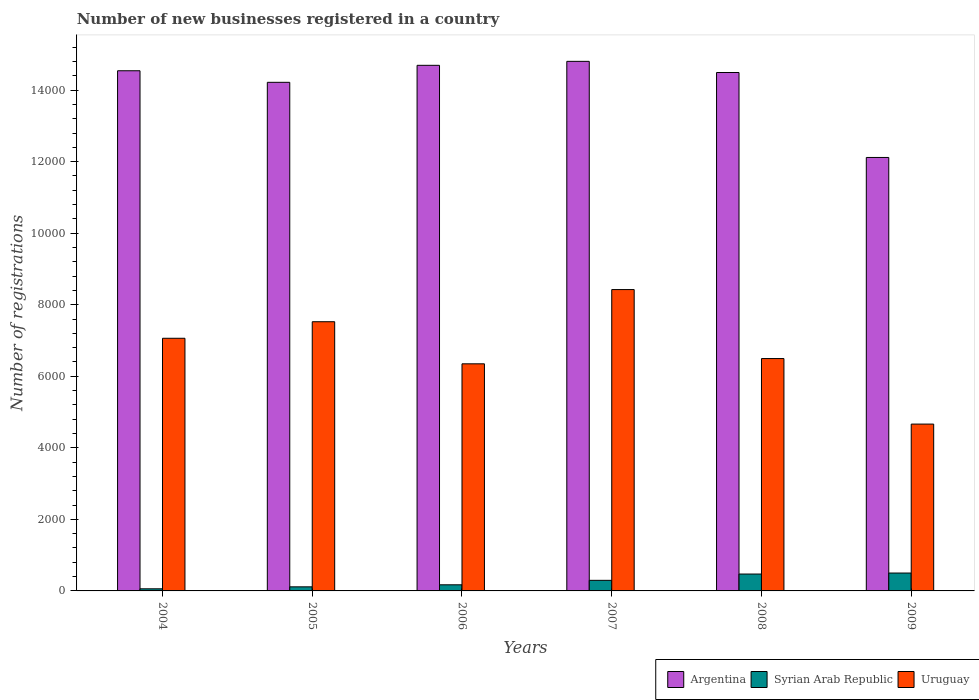How many different coloured bars are there?
Make the answer very short. 3. Are the number of bars on each tick of the X-axis equal?
Your answer should be compact. Yes. How many bars are there on the 6th tick from the left?
Keep it short and to the point. 3. What is the label of the 1st group of bars from the left?
Your answer should be compact. 2004. What is the number of new businesses registered in Uruguay in 2006?
Offer a terse response. 6349. Across all years, what is the maximum number of new businesses registered in Argentina?
Make the answer very short. 1.48e+04. Across all years, what is the minimum number of new businesses registered in Argentina?
Your answer should be compact. 1.21e+04. In which year was the number of new businesses registered in Uruguay maximum?
Provide a short and direct response. 2007. In which year was the number of new businesses registered in Syrian Arab Republic minimum?
Make the answer very short. 2004. What is the total number of new businesses registered in Syrian Arab Republic in the graph?
Your answer should be very brief. 1612. What is the difference between the number of new businesses registered in Syrian Arab Republic in 2007 and that in 2009?
Your answer should be very brief. -204. What is the difference between the number of new businesses registered in Argentina in 2007 and the number of new businesses registered in Uruguay in 2005?
Your answer should be very brief. 7279. What is the average number of new businesses registered in Syrian Arab Republic per year?
Make the answer very short. 268.67. In the year 2007, what is the difference between the number of new businesses registered in Syrian Arab Republic and number of new businesses registered in Uruguay?
Keep it short and to the point. -8129. What is the ratio of the number of new businesses registered in Syrian Arab Republic in 2005 to that in 2006?
Keep it short and to the point. 0.67. Is the difference between the number of new businesses registered in Syrian Arab Republic in 2005 and 2009 greater than the difference between the number of new businesses registered in Uruguay in 2005 and 2009?
Provide a short and direct response. No. What is the difference between the highest and the second highest number of new businesses registered in Argentina?
Keep it short and to the point. 111. What is the difference between the highest and the lowest number of new businesses registered in Uruguay?
Give a very brief answer. 3761. Is the sum of the number of new businesses registered in Argentina in 2005 and 2006 greater than the maximum number of new businesses registered in Uruguay across all years?
Offer a very short reply. Yes. What does the 1st bar from the left in 2005 represents?
Provide a succinct answer. Argentina. What does the 1st bar from the right in 2009 represents?
Your response must be concise. Uruguay. Is it the case that in every year, the sum of the number of new businesses registered in Syrian Arab Republic and number of new businesses registered in Uruguay is greater than the number of new businesses registered in Argentina?
Provide a short and direct response. No. How many bars are there?
Ensure brevity in your answer.  18. Does the graph contain any zero values?
Make the answer very short. No. Where does the legend appear in the graph?
Ensure brevity in your answer.  Bottom right. How are the legend labels stacked?
Keep it short and to the point. Horizontal. What is the title of the graph?
Make the answer very short. Number of new businesses registered in a country. What is the label or title of the X-axis?
Keep it short and to the point. Years. What is the label or title of the Y-axis?
Keep it short and to the point. Number of registrations. What is the Number of registrations of Argentina in 2004?
Ensure brevity in your answer.  1.45e+04. What is the Number of registrations in Syrian Arab Republic in 2004?
Ensure brevity in your answer.  59. What is the Number of registrations of Uruguay in 2004?
Your answer should be very brief. 7063. What is the Number of registrations in Argentina in 2005?
Provide a short and direct response. 1.42e+04. What is the Number of registrations of Syrian Arab Republic in 2005?
Offer a terse response. 114. What is the Number of registrations in Uruguay in 2005?
Keep it short and to the point. 7526. What is the Number of registrations in Argentina in 2006?
Offer a very short reply. 1.47e+04. What is the Number of registrations of Syrian Arab Republic in 2006?
Provide a short and direct response. 171. What is the Number of registrations of Uruguay in 2006?
Offer a very short reply. 6349. What is the Number of registrations of Argentina in 2007?
Your response must be concise. 1.48e+04. What is the Number of registrations in Syrian Arab Republic in 2007?
Provide a short and direct response. 296. What is the Number of registrations in Uruguay in 2007?
Your response must be concise. 8425. What is the Number of registrations in Argentina in 2008?
Ensure brevity in your answer.  1.45e+04. What is the Number of registrations in Syrian Arab Republic in 2008?
Your answer should be very brief. 472. What is the Number of registrations of Uruguay in 2008?
Your answer should be very brief. 6496. What is the Number of registrations of Argentina in 2009?
Offer a terse response. 1.21e+04. What is the Number of registrations of Uruguay in 2009?
Offer a very short reply. 4664. Across all years, what is the maximum Number of registrations of Argentina?
Your response must be concise. 1.48e+04. Across all years, what is the maximum Number of registrations in Syrian Arab Republic?
Offer a very short reply. 500. Across all years, what is the maximum Number of registrations in Uruguay?
Your answer should be compact. 8425. Across all years, what is the minimum Number of registrations in Argentina?
Offer a very short reply. 1.21e+04. Across all years, what is the minimum Number of registrations in Uruguay?
Your answer should be very brief. 4664. What is the total Number of registrations in Argentina in the graph?
Offer a terse response. 8.49e+04. What is the total Number of registrations in Syrian Arab Republic in the graph?
Your response must be concise. 1612. What is the total Number of registrations in Uruguay in the graph?
Provide a succinct answer. 4.05e+04. What is the difference between the Number of registrations of Argentina in 2004 and that in 2005?
Give a very brief answer. 323. What is the difference between the Number of registrations in Syrian Arab Republic in 2004 and that in 2005?
Provide a succinct answer. -55. What is the difference between the Number of registrations of Uruguay in 2004 and that in 2005?
Keep it short and to the point. -463. What is the difference between the Number of registrations in Argentina in 2004 and that in 2006?
Offer a terse response. -152. What is the difference between the Number of registrations of Syrian Arab Republic in 2004 and that in 2006?
Offer a terse response. -112. What is the difference between the Number of registrations in Uruguay in 2004 and that in 2006?
Your answer should be compact. 714. What is the difference between the Number of registrations in Argentina in 2004 and that in 2007?
Give a very brief answer. -263. What is the difference between the Number of registrations of Syrian Arab Republic in 2004 and that in 2007?
Offer a terse response. -237. What is the difference between the Number of registrations of Uruguay in 2004 and that in 2007?
Offer a terse response. -1362. What is the difference between the Number of registrations of Syrian Arab Republic in 2004 and that in 2008?
Provide a short and direct response. -413. What is the difference between the Number of registrations of Uruguay in 2004 and that in 2008?
Provide a short and direct response. 567. What is the difference between the Number of registrations in Argentina in 2004 and that in 2009?
Your response must be concise. 2424. What is the difference between the Number of registrations of Syrian Arab Republic in 2004 and that in 2009?
Provide a short and direct response. -441. What is the difference between the Number of registrations of Uruguay in 2004 and that in 2009?
Ensure brevity in your answer.  2399. What is the difference between the Number of registrations of Argentina in 2005 and that in 2006?
Your answer should be compact. -475. What is the difference between the Number of registrations in Syrian Arab Republic in 2005 and that in 2006?
Ensure brevity in your answer.  -57. What is the difference between the Number of registrations in Uruguay in 2005 and that in 2006?
Give a very brief answer. 1177. What is the difference between the Number of registrations in Argentina in 2005 and that in 2007?
Provide a short and direct response. -586. What is the difference between the Number of registrations of Syrian Arab Republic in 2005 and that in 2007?
Ensure brevity in your answer.  -182. What is the difference between the Number of registrations of Uruguay in 2005 and that in 2007?
Make the answer very short. -899. What is the difference between the Number of registrations of Argentina in 2005 and that in 2008?
Make the answer very short. -274. What is the difference between the Number of registrations of Syrian Arab Republic in 2005 and that in 2008?
Your answer should be compact. -358. What is the difference between the Number of registrations of Uruguay in 2005 and that in 2008?
Your response must be concise. 1030. What is the difference between the Number of registrations in Argentina in 2005 and that in 2009?
Offer a very short reply. 2101. What is the difference between the Number of registrations of Syrian Arab Republic in 2005 and that in 2009?
Offer a very short reply. -386. What is the difference between the Number of registrations of Uruguay in 2005 and that in 2009?
Offer a terse response. 2862. What is the difference between the Number of registrations in Argentina in 2006 and that in 2007?
Provide a succinct answer. -111. What is the difference between the Number of registrations in Syrian Arab Republic in 2006 and that in 2007?
Make the answer very short. -125. What is the difference between the Number of registrations in Uruguay in 2006 and that in 2007?
Make the answer very short. -2076. What is the difference between the Number of registrations in Argentina in 2006 and that in 2008?
Give a very brief answer. 201. What is the difference between the Number of registrations in Syrian Arab Republic in 2006 and that in 2008?
Provide a short and direct response. -301. What is the difference between the Number of registrations in Uruguay in 2006 and that in 2008?
Keep it short and to the point. -147. What is the difference between the Number of registrations in Argentina in 2006 and that in 2009?
Make the answer very short. 2576. What is the difference between the Number of registrations in Syrian Arab Republic in 2006 and that in 2009?
Ensure brevity in your answer.  -329. What is the difference between the Number of registrations of Uruguay in 2006 and that in 2009?
Give a very brief answer. 1685. What is the difference between the Number of registrations of Argentina in 2007 and that in 2008?
Ensure brevity in your answer.  312. What is the difference between the Number of registrations of Syrian Arab Republic in 2007 and that in 2008?
Offer a very short reply. -176. What is the difference between the Number of registrations in Uruguay in 2007 and that in 2008?
Make the answer very short. 1929. What is the difference between the Number of registrations of Argentina in 2007 and that in 2009?
Provide a succinct answer. 2687. What is the difference between the Number of registrations in Syrian Arab Republic in 2007 and that in 2009?
Your answer should be compact. -204. What is the difference between the Number of registrations of Uruguay in 2007 and that in 2009?
Your answer should be compact. 3761. What is the difference between the Number of registrations in Argentina in 2008 and that in 2009?
Ensure brevity in your answer.  2375. What is the difference between the Number of registrations in Syrian Arab Republic in 2008 and that in 2009?
Your answer should be compact. -28. What is the difference between the Number of registrations in Uruguay in 2008 and that in 2009?
Your answer should be very brief. 1832. What is the difference between the Number of registrations in Argentina in 2004 and the Number of registrations in Syrian Arab Republic in 2005?
Offer a terse response. 1.44e+04. What is the difference between the Number of registrations of Argentina in 2004 and the Number of registrations of Uruguay in 2005?
Your response must be concise. 7016. What is the difference between the Number of registrations in Syrian Arab Republic in 2004 and the Number of registrations in Uruguay in 2005?
Offer a terse response. -7467. What is the difference between the Number of registrations of Argentina in 2004 and the Number of registrations of Syrian Arab Republic in 2006?
Make the answer very short. 1.44e+04. What is the difference between the Number of registrations of Argentina in 2004 and the Number of registrations of Uruguay in 2006?
Offer a terse response. 8193. What is the difference between the Number of registrations in Syrian Arab Republic in 2004 and the Number of registrations in Uruguay in 2006?
Give a very brief answer. -6290. What is the difference between the Number of registrations of Argentina in 2004 and the Number of registrations of Syrian Arab Republic in 2007?
Provide a short and direct response. 1.42e+04. What is the difference between the Number of registrations of Argentina in 2004 and the Number of registrations of Uruguay in 2007?
Your answer should be compact. 6117. What is the difference between the Number of registrations of Syrian Arab Republic in 2004 and the Number of registrations of Uruguay in 2007?
Keep it short and to the point. -8366. What is the difference between the Number of registrations in Argentina in 2004 and the Number of registrations in Syrian Arab Republic in 2008?
Give a very brief answer. 1.41e+04. What is the difference between the Number of registrations of Argentina in 2004 and the Number of registrations of Uruguay in 2008?
Give a very brief answer. 8046. What is the difference between the Number of registrations in Syrian Arab Republic in 2004 and the Number of registrations in Uruguay in 2008?
Offer a terse response. -6437. What is the difference between the Number of registrations of Argentina in 2004 and the Number of registrations of Syrian Arab Republic in 2009?
Keep it short and to the point. 1.40e+04. What is the difference between the Number of registrations of Argentina in 2004 and the Number of registrations of Uruguay in 2009?
Your response must be concise. 9878. What is the difference between the Number of registrations in Syrian Arab Republic in 2004 and the Number of registrations in Uruguay in 2009?
Offer a terse response. -4605. What is the difference between the Number of registrations in Argentina in 2005 and the Number of registrations in Syrian Arab Republic in 2006?
Offer a very short reply. 1.40e+04. What is the difference between the Number of registrations in Argentina in 2005 and the Number of registrations in Uruguay in 2006?
Offer a very short reply. 7870. What is the difference between the Number of registrations in Syrian Arab Republic in 2005 and the Number of registrations in Uruguay in 2006?
Offer a terse response. -6235. What is the difference between the Number of registrations of Argentina in 2005 and the Number of registrations of Syrian Arab Republic in 2007?
Make the answer very short. 1.39e+04. What is the difference between the Number of registrations of Argentina in 2005 and the Number of registrations of Uruguay in 2007?
Offer a terse response. 5794. What is the difference between the Number of registrations of Syrian Arab Republic in 2005 and the Number of registrations of Uruguay in 2007?
Your response must be concise. -8311. What is the difference between the Number of registrations of Argentina in 2005 and the Number of registrations of Syrian Arab Republic in 2008?
Make the answer very short. 1.37e+04. What is the difference between the Number of registrations in Argentina in 2005 and the Number of registrations in Uruguay in 2008?
Offer a terse response. 7723. What is the difference between the Number of registrations of Syrian Arab Republic in 2005 and the Number of registrations of Uruguay in 2008?
Your response must be concise. -6382. What is the difference between the Number of registrations of Argentina in 2005 and the Number of registrations of Syrian Arab Republic in 2009?
Make the answer very short. 1.37e+04. What is the difference between the Number of registrations in Argentina in 2005 and the Number of registrations in Uruguay in 2009?
Offer a terse response. 9555. What is the difference between the Number of registrations of Syrian Arab Republic in 2005 and the Number of registrations of Uruguay in 2009?
Provide a succinct answer. -4550. What is the difference between the Number of registrations in Argentina in 2006 and the Number of registrations in Syrian Arab Republic in 2007?
Offer a very short reply. 1.44e+04. What is the difference between the Number of registrations of Argentina in 2006 and the Number of registrations of Uruguay in 2007?
Ensure brevity in your answer.  6269. What is the difference between the Number of registrations in Syrian Arab Republic in 2006 and the Number of registrations in Uruguay in 2007?
Your answer should be compact. -8254. What is the difference between the Number of registrations of Argentina in 2006 and the Number of registrations of Syrian Arab Republic in 2008?
Offer a very short reply. 1.42e+04. What is the difference between the Number of registrations of Argentina in 2006 and the Number of registrations of Uruguay in 2008?
Give a very brief answer. 8198. What is the difference between the Number of registrations in Syrian Arab Republic in 2006 and the Number of registrations in Uruguay in 2008?
Offer a very short reply. -6325. What is the difference between the Number of registrations in Argentina in 2006 and the Number of registrations in Syrian Arab Republic in 2009?
Your answer should be very brief. 1.42e+04. What is the difference between the Number of registrations of Argentina in 2006 and the Number of registrations of Uruguay in 2009?
Offer a very short reply. 1.00e+04. What is the difference between the Number of registrations of Syrian Arab Republic in 2006 and the Number of registrations of Uruguay in 2009?
Your answer should be compact. -4493. What is the difference between the Number of registrations of Argentina in 2007 and the Number of registrations of Syrian Arab Republic in 2008?
Give a very brief answer. 1.43e+04. What is the difference between the Number of registrations of Argentina in 2007 and the Number of registrations of Uruguay in 2008?
Make the answer very short. 8309. What is the difference between the Number of registrations in Syrian Arab Republic in 2007 and the Number of registrations in Uruguay in 2008?
Your answer should be compact. -6200. What is the difference between the Number of registrations of Argentina in 2007 and the Number of registrations of Syrian Arab Republic in 2009?
Ensure brevity in your answer.  1.43e+04. What is the difference between the Number of registrations of Argentina in 2007 and the Number of registrations of Uruguay in 2009?
Provide a short and direct response. 1.01e+04. What is the difference between the Number of registrations of Syrian Arab Republic in 2007 and the Number of registrations of Uruguay in 2009?
Provide a short and direct response. -4368. What is the difference between the Number of registrations of Argentina in 2008 and the Number of registrations of Syrian Arab Republic in 2009?
Offer a terse response. 1.40e+04. What is the difference between the Number of registrations in Argentina in 2008 and the Number of registrations in Uruguay in 2009?
Keep it short and to the point. 9829. What is the difference between the Number of registrations of Syrian Arab Republic in 2008 and the Number of registrations of Uruguay in 2009?
Offer a terse response. -4192. What is the average Number of registrations of Argentina per year?
Your answer should be compact. 1.41e+04. What is the average Number of registrations in Syrian Arab Republic per year?
Ensure brevity in your answer.  268.67. What is the average Number of registrations in Uruguay per year?
Your answer should be compact. 6753.83. In the year 2004, what is the difference between the Number of registrations of Argentina and Number of registrations of Syrian Arab Republic?
Keep it short and to the point. 1.45e+04. In the year 2004, what is the difference between the Number of registrations in Argentina and Number of registrations in Uruguay?
Offer a very short reply. 7479. In the year 2004, what is the difference between the Number of registrations in Syrian Arab Republic and Number of registrations in Uruguay?
Provide a short and direct response. -7004. In the year 2005, what is the difference between the Number of registrations of Argentina and Number of registrations of Syrian Arab Republic?
Offer a terse response. 1.41e+04. In the year 2005, what is the difference between the Number of registrations in Argentina and Number of registrations in Uruguay?
Keep it short and to the point. 6693. In the year 2005, what is the difference between the Number of registrations of Syrian Arab Republic and Number of registrations of Uruguay?
Ensure brevity in your answer.  -7412. In the year 2006, what is the difference between the Number of registrations of Argentina and Number of registrations of Syrian Arab Republic?
Offer a very short reply. 1.45e+04. In the year 2006, what is the difference between the Number of registrations of Argentina and Number of registrations of Uruguay?
Offer a very short reply. 8345. In the year 2006, what is the difference between the Number of registrations in Syrian Arab Republic and Number of registrations in Uruguay?
Make the answer very short. -6178. In the year 2007, what is the difference between the Number of registrations of Argentina and Number of registrations of Syrian Arab Republic?
Your answer should be compact. 1.45e+04. In the year 2007, what is the difference between the Number of registrations in Argentina and Number of registrations in Uruguay?
Your answer should be very brief. 6380. In the year 2007, what is the difference between the Number of registrations of Syrian Arab Republic and Number of registrations of Uruguay?
Provide a short and direct response. -8129. In the year 2008, what is the difference between the Number of registrations in Argentina and Number of registrations in Syrian Arab Republic?
Your answer should be very brief. 1.40e+04. In the year 2008, what is the difference between the Number of registrations in Argentina and Number of registrations in Uruguay?
Your answer should be compact. 7997. In the year 2008, what is the difference between the Number of registrations of Syrian Arab Republic and Number of registrations of Uruguay?
Your answer should be very brief. -6024. In the year 2009, what is the difference between the Number of registrations of Argentina and Number of registrations of Syrian Arab Republic?
Your answer should be very brief. 1.16e+04. In the year 2009, what is the difference between the Number of registrations of Argentina and Number of registrations of Uruguay?
Provide a succinct answer. 7454. In the year 2009, what is the difference between the Number of registrations in Syrian Arab Republic and Number of registrations in Uruguay?
Provide a short and direct response. -4164. What is the ratio of the Number of registrations in Argentina in 2004 to that in 2005?
Keep it short and to the point. 1.02. What is the ratio of the Number of registrations in Syrian Arab Republic in 2004 to that in 2005?
Offer a terse response. 0.52. What is the ratio of the Number of registrations in Uruguay in 2004 to that in 2005?
Your answer should be compact. 0.94. What is the ratio of the Number of registrations in Argentina in 2004 to that in 2006?
Your answer should be very brief. 0.99. What is the ratio of the Number of registrations of Syrian Arab Republic in 2004 to that in 2006?
Provide a succinct answer. 0.34. What is the ratio of the Number of registrations in Uruguay in 2004 to that in 2006?
Your answer should be very brief. 1.11. What is the ratio of the Number of registrations of Argentina in 2004 to that in 2007?
Your answer should be compact. 0.98. What is the ratio of the Number of registrations in Syrian Arab Republic in 2004 to that in 2007?
Make the answer very short. 0.2. What is the ratio of the Number of registrations in Uruguay in 2004 to that in 2007?
Your response must be concise. 0.84. What is the ratio of the Number of registrations in Uruguay in 2004 to that in 2008?
Provide a succinct answer. 1.09. What is the ratio of the Number of registrations of Argentina in 2004 to that in 2009?
Offer a terse response. 1.2. What is the ratio of the Number of registrations of Syrian Arab Republic in 2004 to that in 2009?
Provide a short and direct response. 0.12. What is the ratio of the Number of registrations of Uruguay in 2004 to that in 2009?
Give a very brief answer. 1.51. What is the ratio of the Number of registrations of Argentina in 2005 to that in 2006?
Make the answer very short. 0.97. What is the ratio of the Number of registrations of Uruguay in 2005 to that in 2006?
Your answer should be compact. 1.19. What is the ratio of the Number of registrations in Argentina in 2005 to that in 2007?
Ensure brevity in your answer.  0.96. What is the ratio of the Number of registrations of Syrian Arab Republic in 2005 to that in 2007?
Make the answer very short. 0.39. What is the ratio of the Number of registrations in Uruguay in 2005 to that in 2007?
Provide a short and direct response. 0.89. What is the ratio of the Number of registrations in Argentina in 2005 to that in 2008?
Give a very brief answer. 0.98. What is the ratio of the Number of registrations in Syrian Arab Republic in 2005 to that in 2008?
Give a very brief answer. 0.24. What is the ratio of the Number of registrations in Uruguay in 2005 to that in 2008?
Offer a terse response. 1.16. What is the ratio of the Number of registrations in Argentina in 2005 to that in 2009?
Provide a succinct answer. 1.17. What is the ratio of the Number of registrations in Syrian Arab Republic in 2005 to that in 2009?
Your answer should be very brief. 0.23. What is the ratio of the Number of registrations in Uruguay in 2005 to that in 2009?
Provide a succinct answer. 1.61. What is the ratio of the Number of registrations of Argentina in 2006 to that in 2007?
Offer a terse response. 0.99. What is the ratio of the Number of registrations in Syrian Arab Republic in 2006 to that in 2007?
Offer a terse response. 0.58. What is the ratio of the Number of registrations of Uruguay in 2006 to that in 2007?
Keep it short and to the point. 0.75. What is the ratio of the Number of registrations in Argentina in 2006 to that in 2008?
Provide a short and direct response. 1.01. What is the ratio of the Number of registrations in Syrian Arab Republic in 2006 to that in 2008?
Offer a very short reply. 0.36. What is the ratio of the Number of registrations in Uruguay in 2006 to that in 2008?
Make the answer very short. 0.98. What is the ratio of the Number of registrations in Argentina in 2006 to that in 2009?
Provide a short and direct response. 1.21. What is the ratio of the Number of registrations of Syrian Arab Republic in 2006 to that in 2009?
Provide a short and direct response. 0.34. What is the ratio of the Number of registrations in Uruguay in 2006 to that in 2009?
Ensure brevity in your answer.  1.36. What is the ratio of the Number of registrations of Argentina in 2007 to that in 2008?
Your answer should be compact. 1.02. What is the ratio of the Number of registrations of Syrian Arab Republic in 2007 to that in 2008?
Make the answer very short. 0.63. What is the ratio of the Number of registrations of Uruguay in 2007 to that in 2008?
Your response must be concise. 1.3. What is the ratio of the Number of registrations of Argentina in 2007 to that in 2009?
Ensure brevity in your answer.  1.22. What is the ratio of the Number of registrations in Syrian Arab Republic in 2007 to that in 2009?
Ensure brevity in your answer.  0.59. What is the ratio of the Number of registrations of Uruguay in 2007 to that in 2009?
Ensure brevity in your answer.  1.81. What is the ratio of the Number of registrations of Argentina in 2008 to that in 2009?
Offer a terse response. 1.2. What is the ratio of the Number of registrations of Syrian Arab Republic in 2008 to that in 2009?
Your response must be concise. 0.94. What is the ratio of the Number of registrations of Uruguay in 2008 to that in 2009?
Provide a succinct answer. 1.39. What is the difference between the highest and the second highest Number of registrations of Argentina?
Keep it short and to the point. 111. What is the difference between the highest and the second highest Number of registrations of Syrian Arab Republic?
Offer a very short reply. 28. What is the difference between the highest and the second highest Number of registrations of Uruguay?
Give a very brief answer. 899. What is the difference between the highest and the lowest Number of registrations of Argentina?
Offer a very short reply. 2687. What is the difference between the highest and the lowest Number of registrations of Syrian Arab Republic?
Give a very brief answer. 441. What is the difference between the highest and the lowest Number of registrations of Uruguay?
Provide a short and direct response. 3761. 